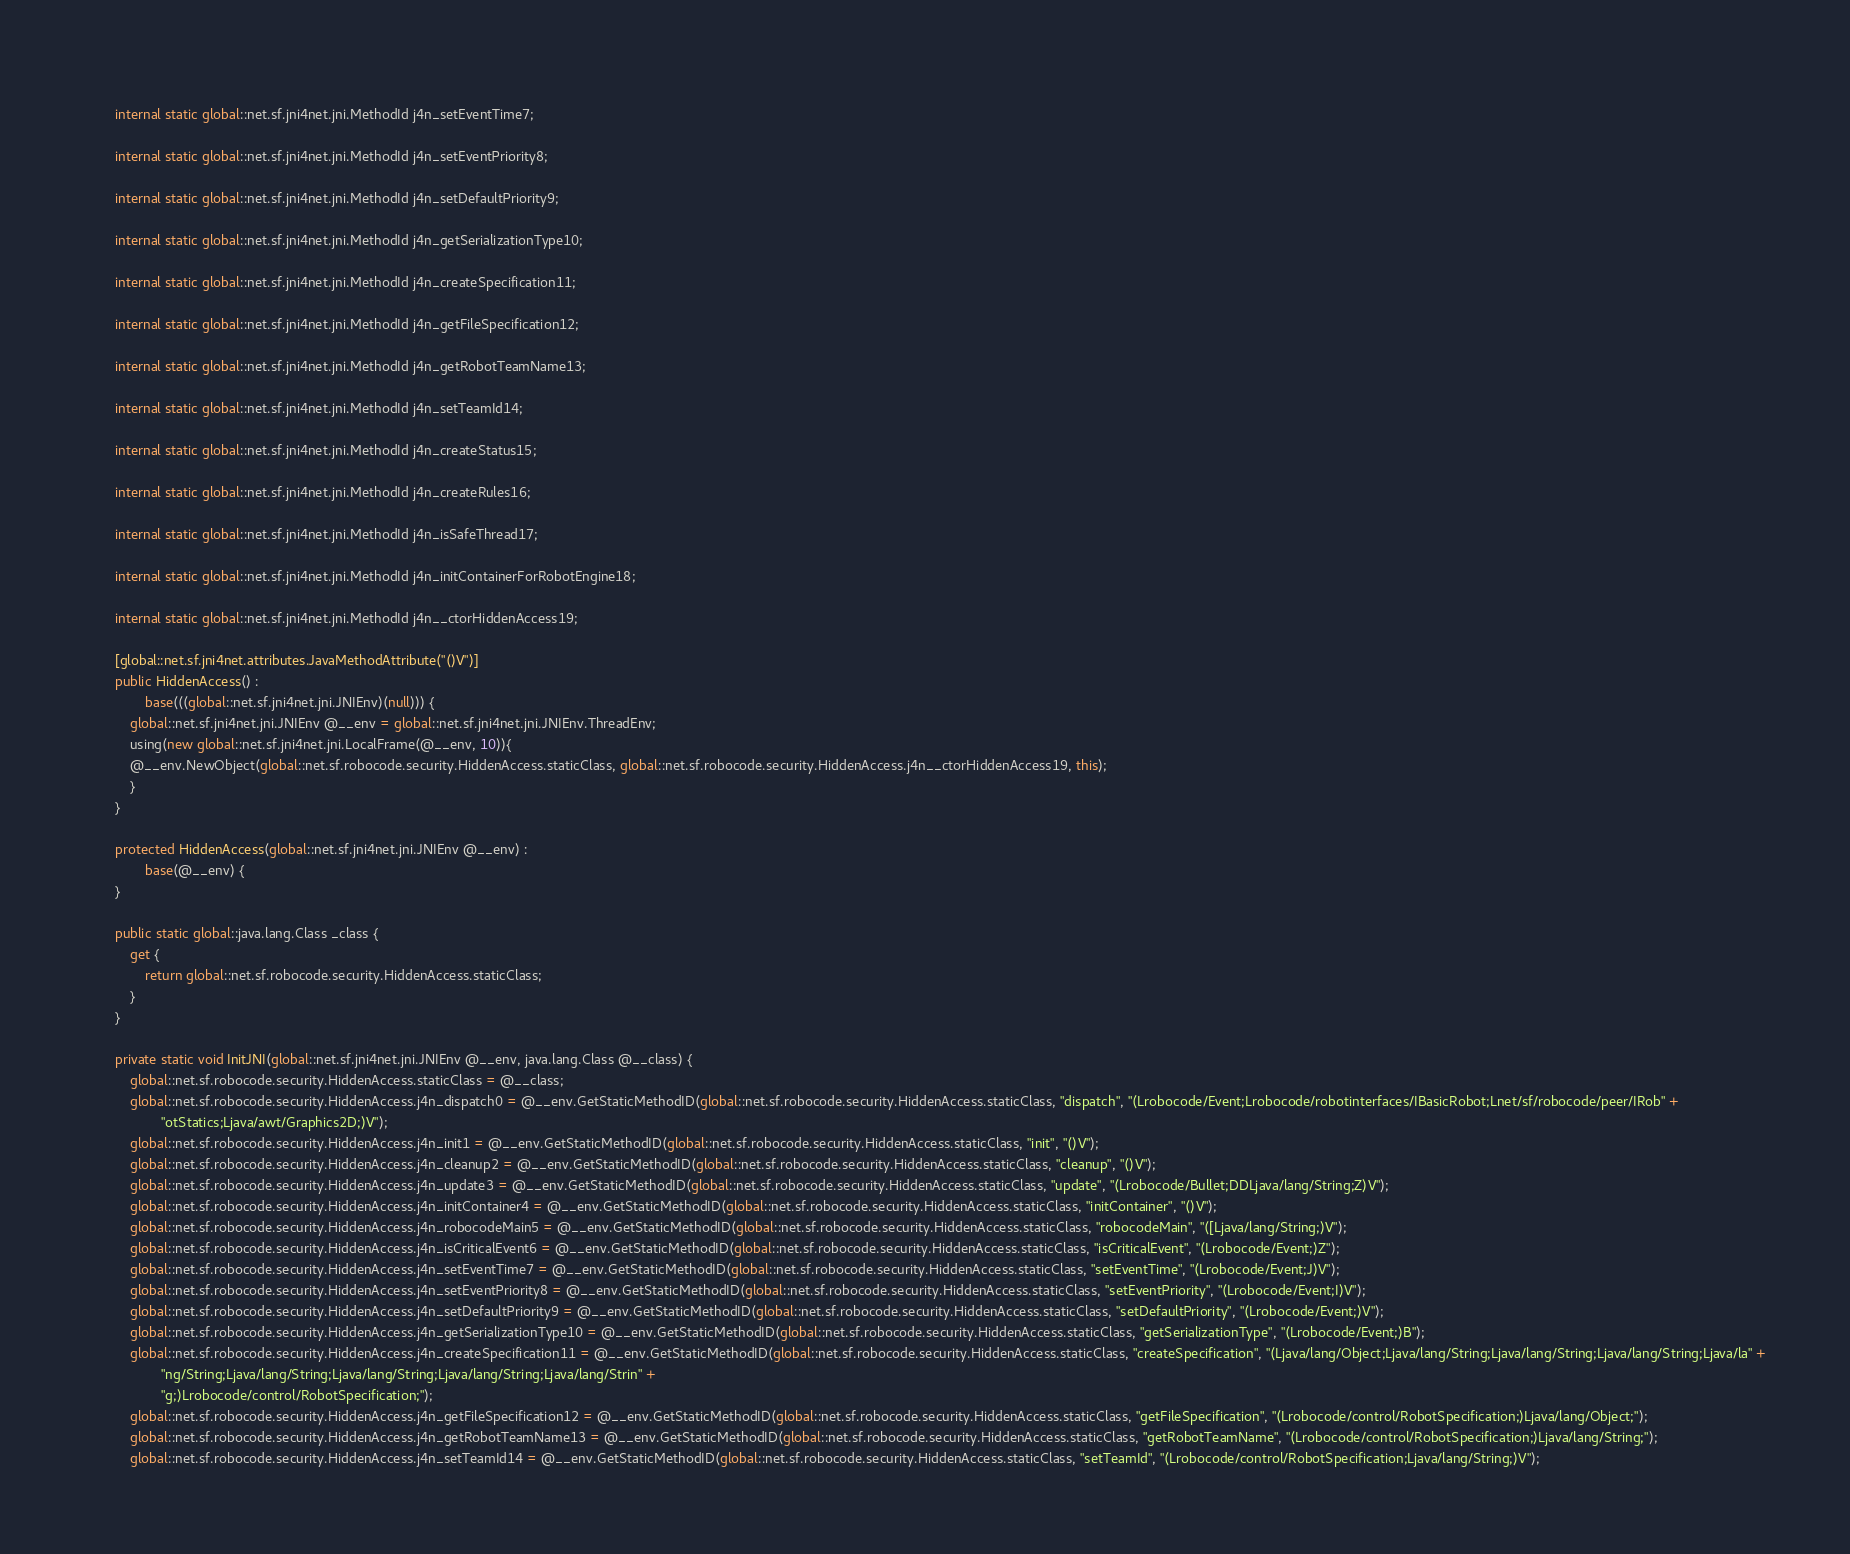<code> <loc_0><loc_0><loc_500><loc_500><_C#_>        
        internal static global::net.sf.jni4net.jni.MethodId j4n_setEventTime7;
        
        internal static global::net.sf.jni4net.jni.MethodId j4n_setEventPriority8;
        
        internal static global::net.sf.jni4net.jni.MethodId j4n_setDefaultPriority9;
        
        internal static global::net.sf.jni4net.jni.MethodId j4n_getSerializationType10;
        
        internal static global::net.sf.jni4net.jni.MethodId j4n_createSpecification11;
        
        internal static global::net.sf.jni4net.jni.MethodId j4n_getFileSpecification12;
        
        internal static global::net.sf.jni4net.jni.MethodId j4n_getRobotTeamName13;
        
        internal static global::net.sf.jni4net.jni.MethodId j4n_setTeamId14;
        
        internal static global::net.sf.jni4net.jni.MethodId j4n_createStatus15;
        
        internal static global::net.sf.jni4net.jni.MethodId j4n_createRules16;
        
        internal static global::net.sf.jni4net.jni.MethodId j4n_isSafeThread17;
        
        internal static global::net.sf.jni4net.jni.MethodId j4n_initContainerForRobotEngine18;
        
        internal static global::net.sf.jni4net.jni.MethodId j4n__ctorHiddenAccess19;
        
        [global::net.sf.jni4net.attributes.JavaMethodAttribute("()V")]
        public HiddenAccess() : 
                base(((global::net.sf.jni4net.jni.JNIEnv)(null))) {
            global::net.sf.jni4net.jni.JNIEnv @__env = global::net.sf.jni4net.jni.JNIEnv.ThreadEnv;
            using(new global::net.sf.jni4net.jni.LocalFrame(@__env, 10)){
            @__env.NewObject(global::net.sf.robocode.security.HiddenAccess.staticClass, global::net.sf.robocode.security.HiddenAccess.j4n__ctorHiddenAccess19, this);
            }
        }
        
        protected HiddenAccess(global::net.sf.jni4net.jni.JNIEnv @__env) : 
                base(@__env) {
        }
        
        public static global::java.lang.Class _class {
            get {
                return global::net.sf.robocode.security.HiddenAccess.staticClass;
            }
        }
        
        private static void InitJNI(global::net.sf.jni4net.jni.JNIEnv @__env, java.lang.Class @__class) {
            global::net.sf.robocode.security.HiddenAccess.staticClass = @__class;
            global::net.sf.robocode.security.HiddenAccess.j4n_dispatch0 = @__env.GetStaticMethodID(global::net.sf.robocode.security.HiddenAccess.staticClass, "dispatch", "(Lrobocode/Event;Lrobocode/robotinterfaces/IBasicRobot;Lnet/sf/robocode/peer/IRob" +
                    "otStatics;Ljava/awt/Graphics2D;)V");
            global::net.sf.robocode.security.HiddenAccess.j4n_init1 = @__env.GetStaticMethodID(global::net.sf.robocode.security.HiddenAccess.staticClass, "init", "()V");
            global::net.sf.robocode.security.HiddenAccess.j4n_cleanup2 = @__env.GetStaticMethodID(global::net.sf.robocode.security.HiddenAccess.staticClass, "cleanup", "()V");
            global::net.sf.robocode.security.HiddenAccess.j4n_update3 = @__env.GetStaticMethodID(global::net.sf.robocode.security.HiddenAccess.staticClass, "update", "(Lrobocode/Bullet;DDLjava/lang/String;Z)V");
            global::net.sf.robocode.security.HiddenAccess.j4n_initContainer4 = @__env.GetStaticMethodID(global::net.sf.robocode.security.HiddenAccess.staticClass, "initContainer", "()V");
            global::net.sf.robocode.security.HiddenAccess.j4n_robocodeMain5 = @__env.GetStaticMethodID(global::net.sf.robocode.security.HiddenAccess.staticClass, "robocodeMain", "([Ljava/lang/String;)V");
            global::net.sf.robocode.security.HiddenAccess.j4n_isCriticalEvent6 = @__env.GetStaticMethodID(global::net.sf.robocode.security.HiddenAccess.staticClass, "isCriticalEvent", "(Lrobocode/Event;)Z");
            global::net.sf.robocode.security.HiddenAccess.j4n_setEventTime7 = @__env.GetStaticMethodID(global::net.sf.robocode.security.HiddenAccess.staticClass, "setEventTime", "(Lrobocode/Event;J)V");
            global::net.sf.robocode.security.HiddenAccess.j4n_setEventPriority8 = @__env.GetStaticMethodID(global::net.sf.robocode.security.HiddenAccess.staticClass, "setEventPriority", "(Lrobocode/Event;I)V");
            global::net.sf.robocode.security.HiddenAccess.j4n_setDefaultPriority9 = @__env.GetStaticMethodID(global::net.sf.robocode.security.HiddenAccess.staticClass, "setDefaultPriority", "(Lrobocode/Event;)V");
            global::net.sf.robocode.security.HiddenAccess.j4n_getSerializationType10 = @__env.GetStaticMethodID(global::net.sf.robocode.security.HiddenAccess.staticClass, "getSerializationType", "(Lrobocode/Event;)B");
            global::net.sf.robocode.security.HiddenAccess.j4n_createSpecification11 = @__env.GetStaticMethodID(global::net.sf.robocode.security.HiddenAccess.staticClass, "createSpecification", "(Ljava/lang/Object;Ljava/lang/String;Ljava/lang/String;Ljava/lang/String;Ljava/la" +
                    "ng/String;Ljava/lang/String;Ljava/lang/String;Ljava/lang/String;Ljava/lang/Strin" +
                    "g;)Lrobocode/control/RobotSpecification;");
            global::net.sf.robocode.security.HiddenAccess.j4n_getFileSpecification12 = @__env.GetStaticMethodID(global::net.sf.robocode.security.HiddenAccess.staticClass, "getFileSpecification", "(Lrobocode/control/RobotSpecification;)Ljava/lang/Object;");
            global::net.sf.robocode.security.HiddenAccess.j4n_getRobotTeamName13 = @__env.GetStaticMethodID(global::net.sf.robocode.security.HiddenAccess.staticClass, "getRobotTeamName", "(Lrobocode/control/RobotSpecification;)Ljava/lang/String;");
            global::net.sf.robocode.security.HiddenAccess.j4n_setTeamId14 = @__env.GetStaticMethodID(global::net.sf.robocode.security.HiddenAccess.staticClass, "setTeamId", "(Lrobocode/control/RobotSpecification;Ljava/lang/String;)V");</code> 